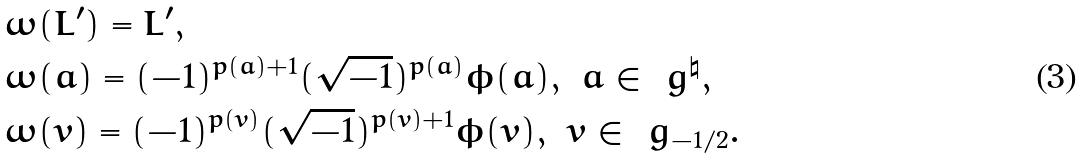<formula> <loc_0><loc_0><loc_500><loc_500>& \omega ( L ^ { \prime } ) = L ^ { \prime } , \\ & \omega ( a ) = ( - 1 ) ^ { p ( a ) + 1 } ( \sqrt { - 1 } ) ^ { p ( a ) } \phi ( a ) , \ a \in \ g ^ { \natural } , \\ & \omega ( v ) = ( - 1 ) ^ { p ( v ) } ( \sqrt { - 1 } ) ^ { p ( v ) + 1 } \phi ( v ) , \ v \in \ g _ { - 1 / 2 } .</formula> 